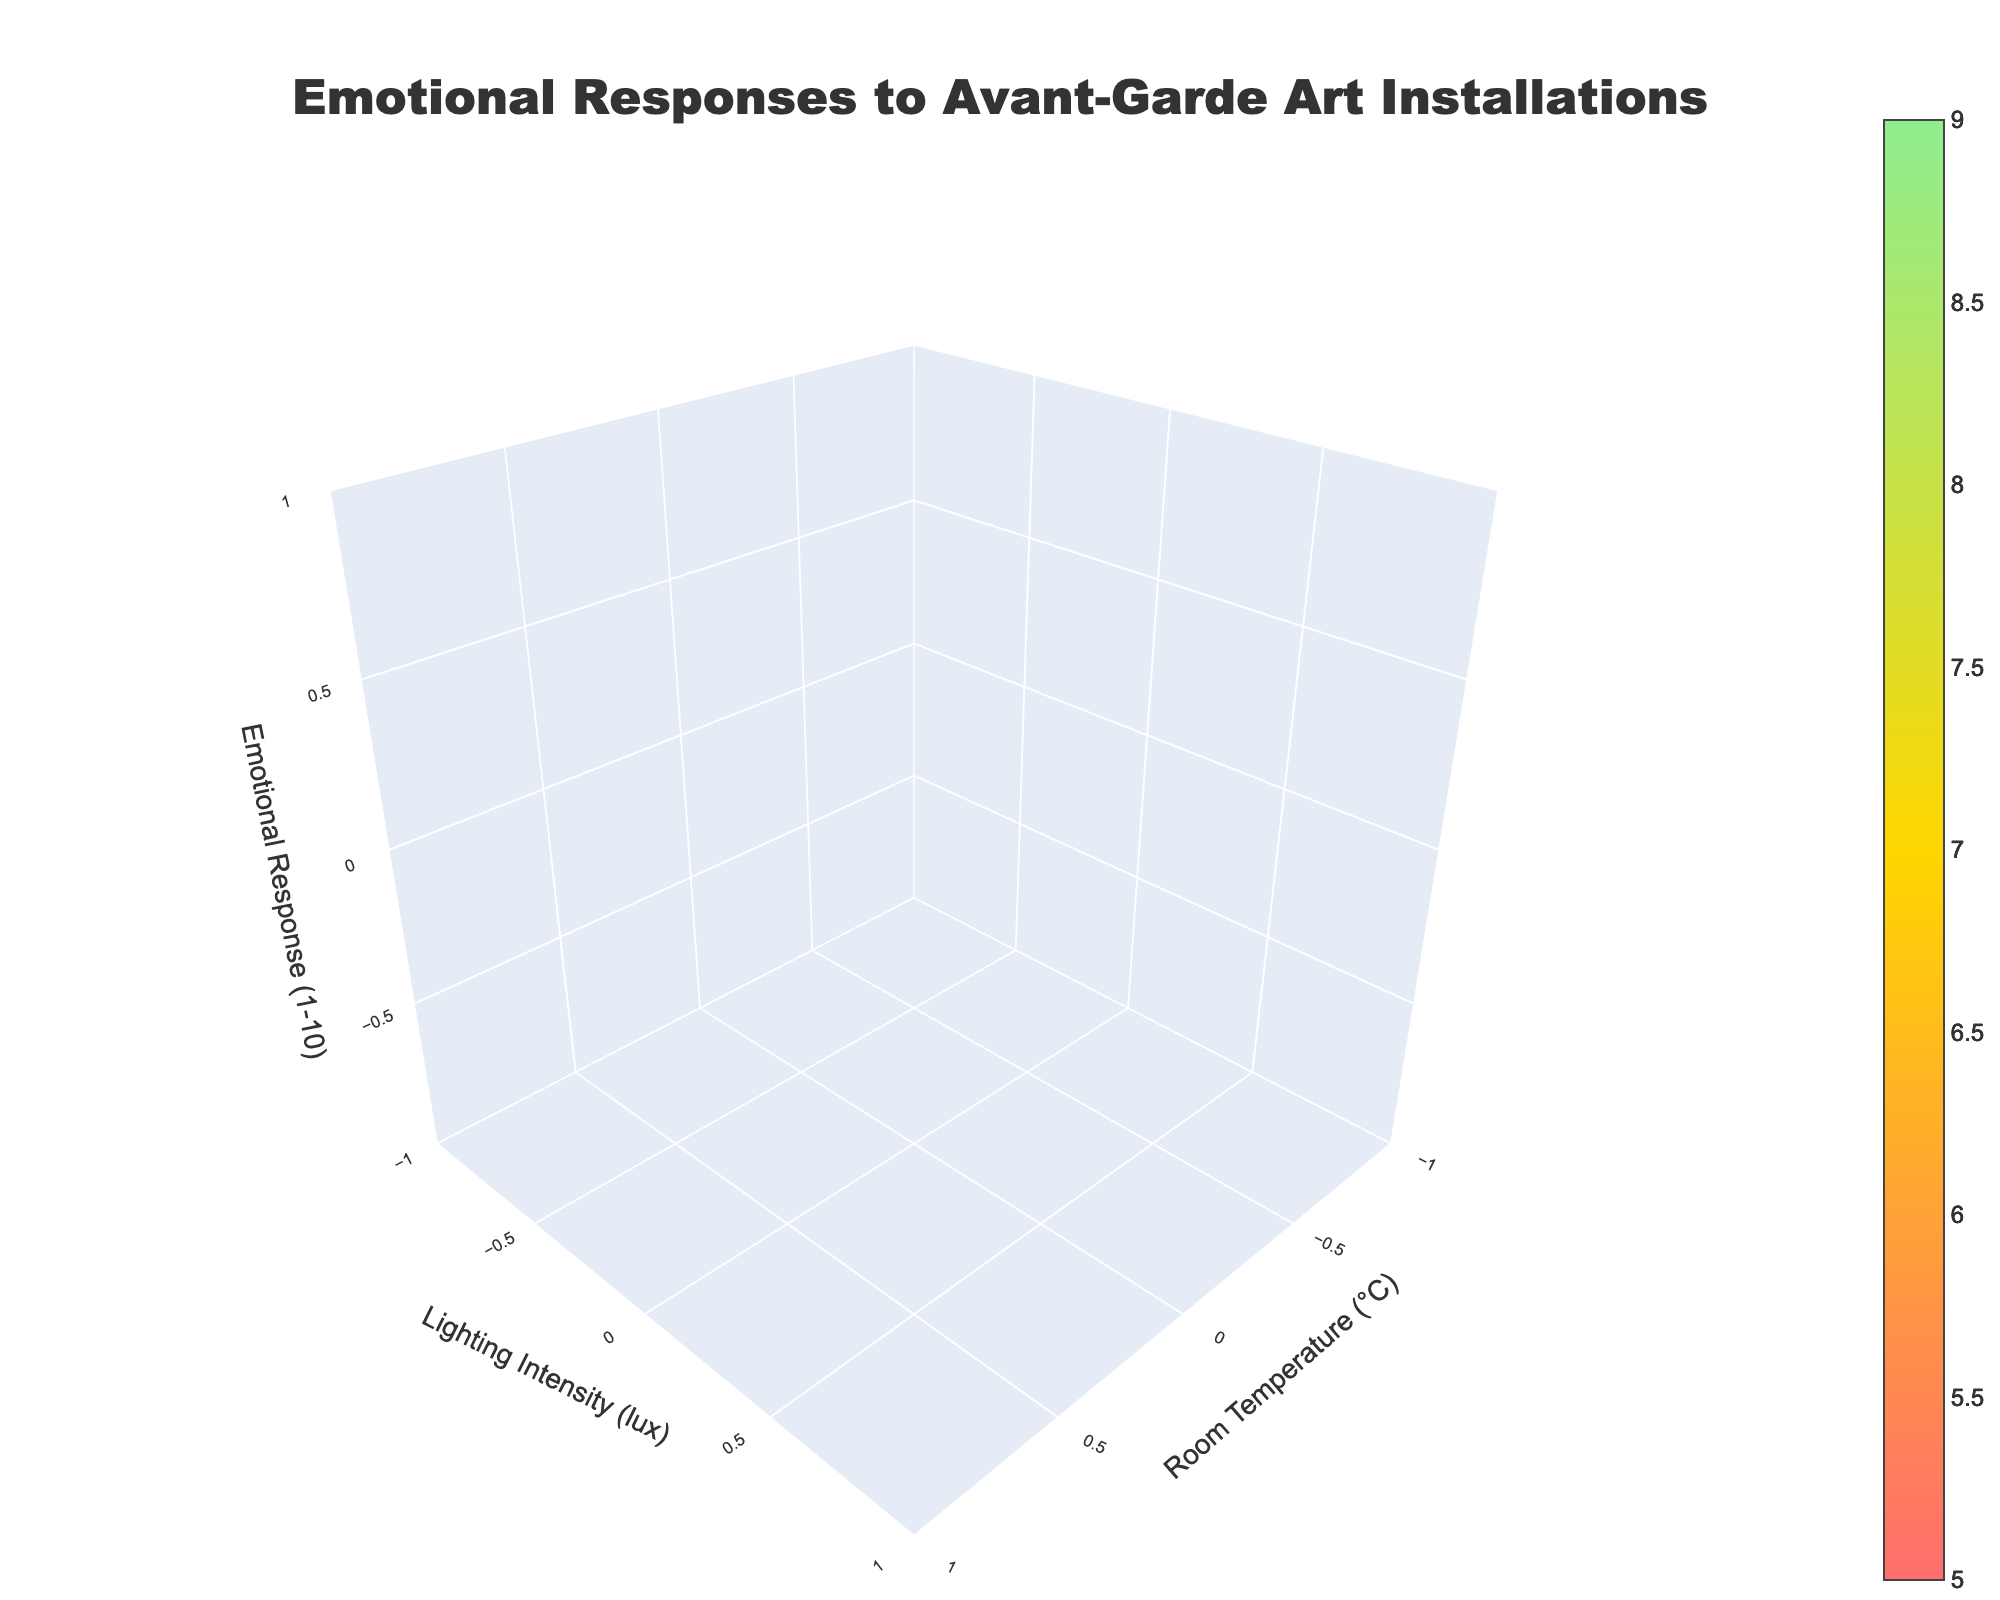How many different art installations are featured in the plot? By looking at the legend or identifying the unique color schemes, determine the number of different art installations.
Answer: 3 What is the emotional response for "The Luminous Void" at 22°C and 300 lux? Refer to the plot, find the point where Room Temperature is 22°C and Lighting Intensity is 300 lux for "The Luminous Void," and read the corresponding Emotional Response value.
Answer: 7.5 Which installation shows the highest emotional response? Compare the peaks of Emotional Response values for all installations and identify which one has the highest value.
Answer: Groves' Shadow At what room temperature and lighting condition does "Echoes of Rivalry" have its lowest emotional response? Scan through the volume representing "Echoes of Rivalry" and identify the minimum Emotional Response along with its corresponding Room Temperature and Lighting Intensity.
Answer: 26°C, 100 lux How does the change in room temperature from 18°C to 26°C affect the emotional response for "Groves' Shadow" under a lighting intensity of 500 lux? Track the Emotional Response for "Groves' Shadow" as Room Temperature increases from 18°C to 26°C under a fixed Lighting Intensity of 500 lux. Note the trend.
Answer: Emotional Response decreases Which installation has the most consistent emotional response across different lighting intensities and room temperatures? Determine the consistency by examining which installation has the least variation in Emotional Response values across the different conditions.
Answer: The Luminous Void What is the approximate emotional response for "Echoes of Rivalry" at 22°C and 500 lux? Refer to the specific conditions (22°C, 500 lux) for "Echoes of Rivalry" and read off the Emotional Response value from the plot.
Answer: 7.7 Compare the emotional responses for "The Luminous Void" and "Groves' Shadow" at 22°C and 100 lux. Identify Emotional Responses for both installations at the specified conditions (22°C, 100 lux) and compare the values.
Answer: 6.8, 7.6 Which installation has the highest emotional response under the lighting intensity of 100 lux? Look at all the installations and pick out the Emotional Responses under 100 lux, then identify the highest one.
Answer: Groves' Shadow What changes in emotional response occur when moving from 100 lux to 500 lux lighting for "The Luminous Void" at a constant room temperature of 22°C? Track and compare the Emotional Response values along the lighting path (from 100 lux to 500 lux) while keeping the Room Temperature at 22°C. Note the trend and changes.
Answer: The emotional response increases from 6.8 to 8.7 